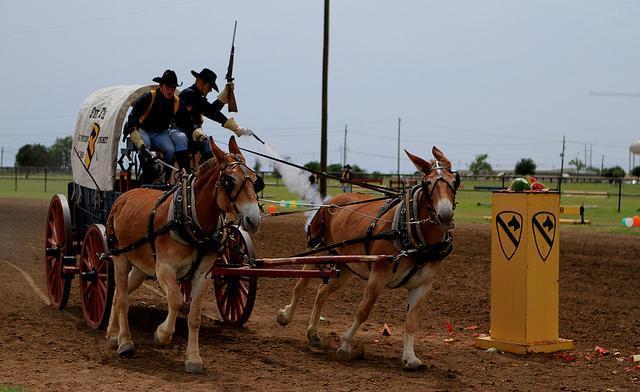How many horses?
Give a very brief answer. 2. How many horses are there?
Give a very brief answer. 2. 